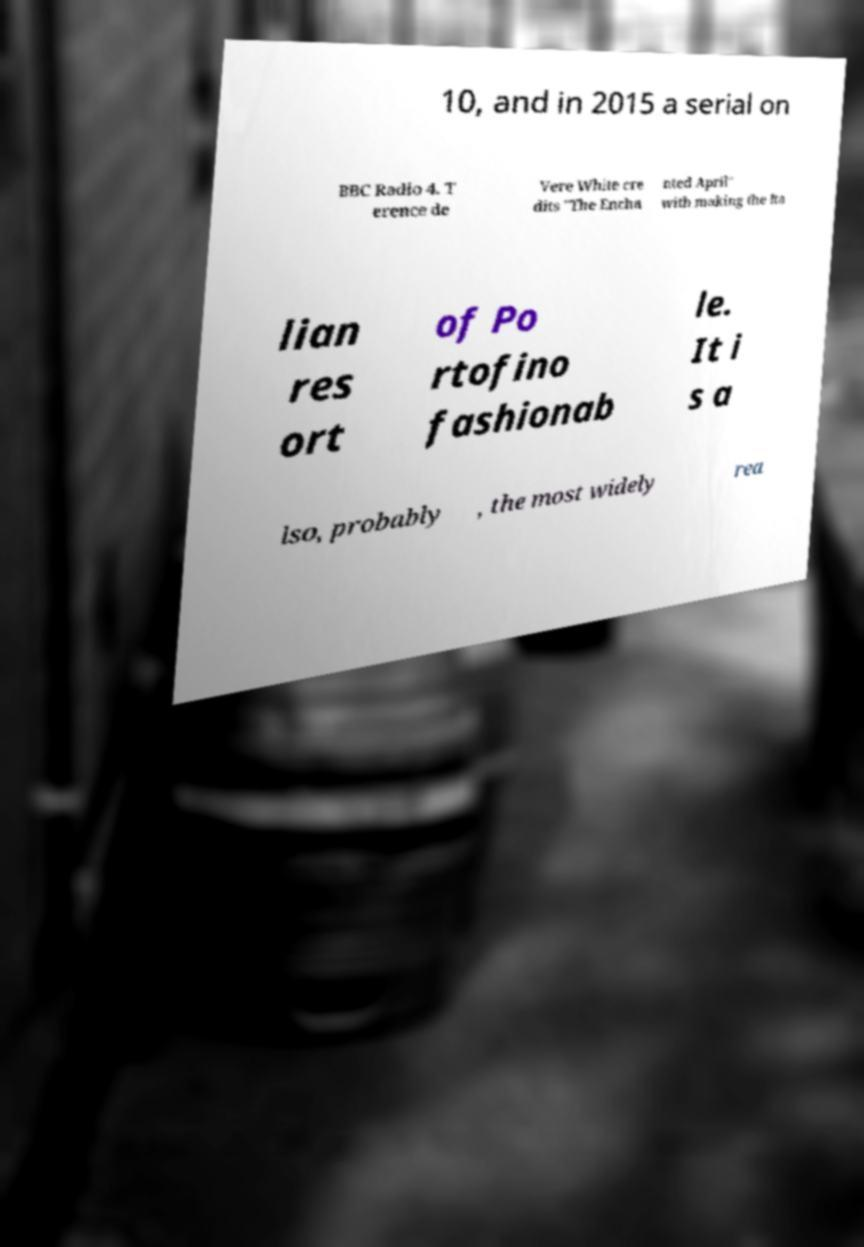There's text embedded in this image that I need extracted. Can you transcribe it verbatim? 10, and in 2015 a serial on BBC Radio 4. T erence de Vere White cre dits "The Encha nted April" with making the Ita lian res ort of Po rtofino fashionab le. It i s a lso, probably , the most widely rea 